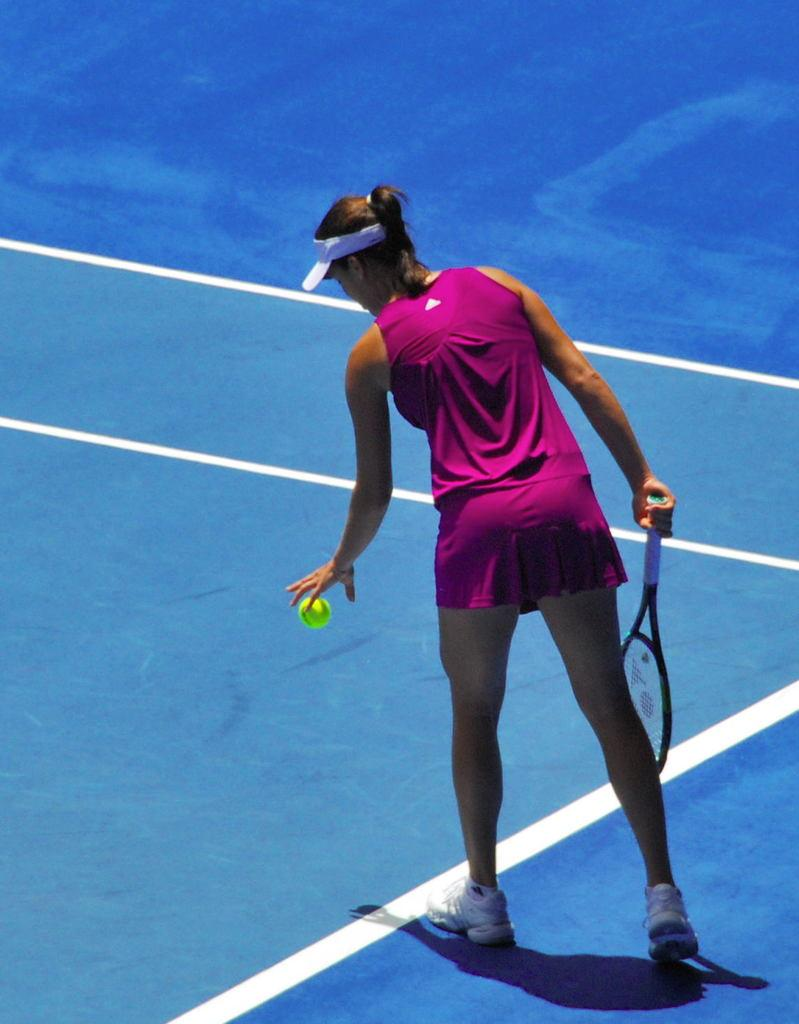Who is the main subject in the image? There is a woman in the image. What activity is the woman engaged in? The woman is playing tennis. What color is the woman's skirt and shirt? The woman is wearing a pink skirt and a pink shirt. What headgear is the woman wearing? The woman is wearing a hat. What type of footwear is the woman wearing? The woman is wearing shoes. How would you describe the weather in the image? The background of the image is sunny. Can you hear the woman's voice in the image? There is no sound in the image, so it is not possible to hear the woman's voice. What is the size of the self in the image? There is no self present in the image; it features a woman playing tennis. 